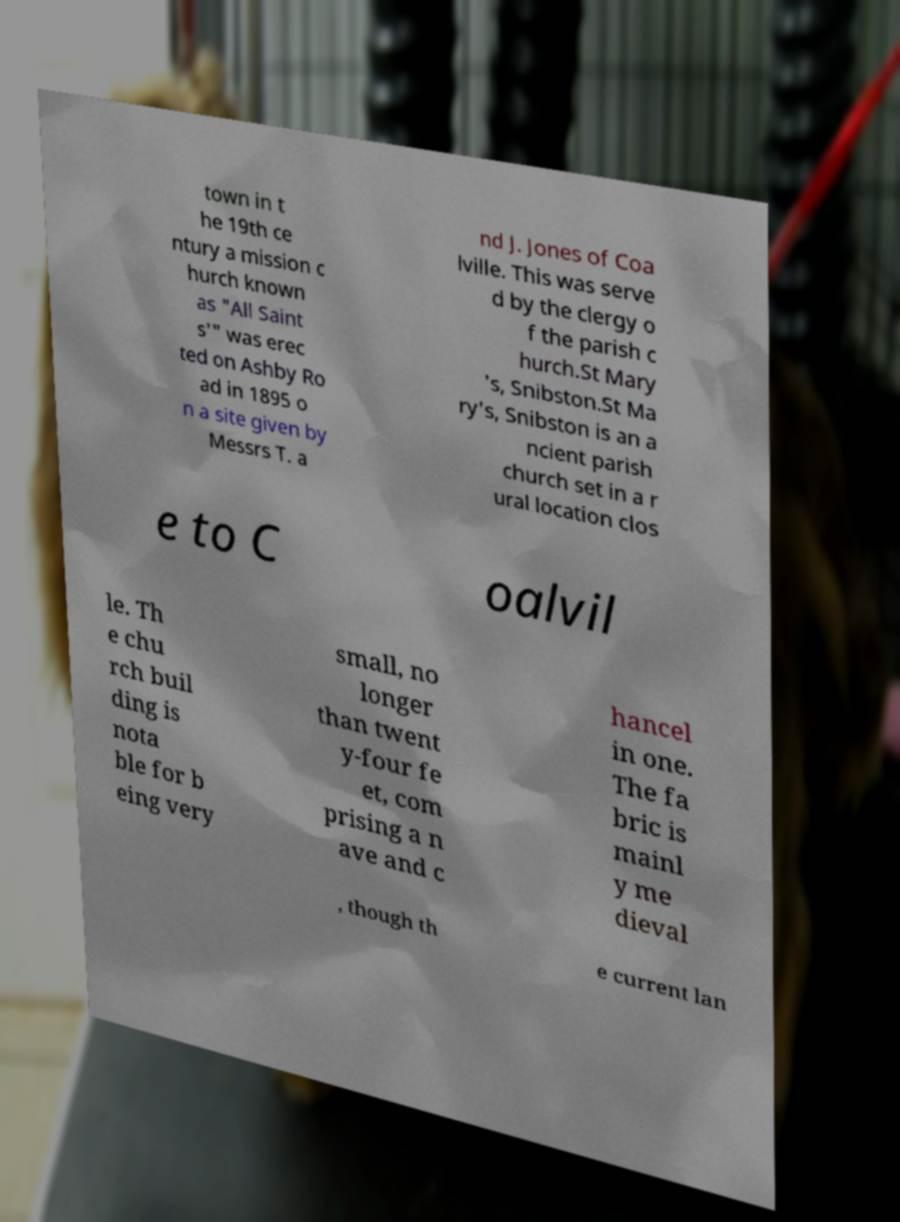What messages or text are displayed in this image? I need them in a readable, typed format. town in t he 19th ce ntury a mission c hurch known as "All Saint s'" was erec ted on Ashby Ro ad in 1895 o n a site given by Messrs T. a nd J. Jones of Coa lville. This was serve d by the clergy o f the parish c hurch.St Mary 's, Snibston.St Ma ry's, Snibston is an a ncient parish church set in a r ural location clos e to C oalvil le. Th e chu rch buil ding is nota ble for b eing very small, no longer than twent y-four fe et, com prising a n ave and c hancel in one. The fa bric is mainl y me dieval , though th e current lan 